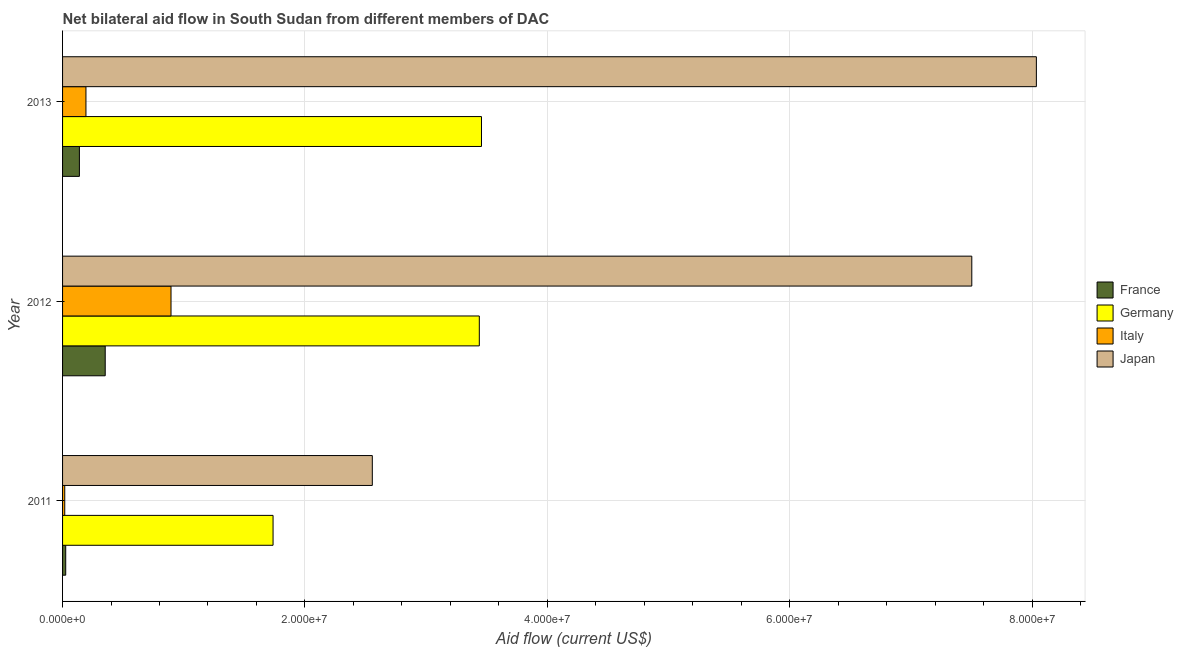Are the number of bars per tick equal to the number of legend labels?
Your response must be concise. Yes. Are the number of bars on each tick of the Y-axis equal?
Make the answer very short. Yes. How many bars are there on the 2nd tick from the bottom?
Provide a succinct answer. 4. In how many cases, is the number of bars for a given year not equal to the number of legend labels?
Offer a terse response. 0. What is the amount of aid given by germany in 2013?
Provide a succinct answer. 3.46e+07. Across all years, what is the maximum amount of aid given by germany?
Your answer should be very brief. 3.46e+07. Across all years, what is the minimum amount of aid given by germany?
Make the answer very short. 1.74e+07. In which year was the amount of aid given by germany maximum?
Your answer should be very brief. 2013. What is the total amount of aid given by japan in the graph?
Offer a terse response. 1.81e+08. What is the difference between the amount of aid given by germany in 2011 and that in 2013?
Your answer should be very brief. -1.72e+07. What is the difference between the amount of aid given by germany in 2012 and the amount of aid given by japan in 2011?
Offer a very short reply. 8.83e+06. What is the average amount of aid given by japan per year?
Provide a short and direct response. 6.03e+07. In the year 2012, what is the difference between the amount of aid given by japan and amount of aid given by germany?
Offer a terse response. 4.06e+07. What is the ratio of the amount of aid given by japan in 2011 to that in 2013?
Your response must be concise. 0.32. Is the amount of aid given by france in 2011 less than that in 2013?
Provide a succinct answer. Yes. What is the difference between the highest and the second highest amount of aid given by italy?
Make the answer very short. 7.02e+06. What is the difference between the highest and the lowest amount of aid given by germany?
Your answer should be very brief. 1.72e+07. In how many years, is the amount of aid given by italy greater than the average amount of aid given by italy taken over all years?
Give a very brief answer. 1. What does the 3rd bar from the top in 2013 represents?
Provide a short and direct response. Germany. What does the 1st bar from the bottom in 2013 represents?
Your answer should be compact. France. Is it the case that in every year, the sum of the amount of aid given by france and amount of aid given by germany is greater than the amount of aid given by italy?
Ensure brevity in your answer.  Yes. How many bars are there?
Make the answer very short. 12. How many years are there in the graph?
Give a very brief answer. 3. Does the graph contain grids?
Your answer should be compact. Yes. Where does the legend appear in the graph?
Your response must be concise. Center right. How many legend labels are there?
Your answer should be very brief. 4. How are the legend labels stacked?
Provide a succinct answer. Vertical. What is the title of the graph?
Provide a short and direct response. Net bilateral aid flow in South Sudan from different members of DAC. Does "UNHCR" appear as one of the legend labels in the graph?
Your response must be concise. No. What is the label or title of the Y-axis?
Provide a short and direct response. Year. What is the Aid flow (current US$) of France in 2011?
Offer a very short reply. 2.60e+05. What is the Aid flow (current US$) in Germany in 2011?
Keep it short and to the point. 1.74e+07. What is the Aid flow (current US$) of Japan in 2011?
Provide a short and direct response. 2.56e+07. What is the Aid flow (current US$) of France in 2012?
Ensure brevity in your answer.  3.52e+06. What is the Aid flow (current US$) of Germany in 2012?
Your answer should be compact. 3.44e+07. What is the Aid flow (current US$) of Italy in 2012?
Your answer should be very brief. 8.95e+06. What is the Aid flow (current US$) in Japan in 2012?
Your answer should be compact. 7.50e+07. What is the Aid flow (current US$) in France in 2013?
Your response must be concise. 1.39e+06. What is the Aid flow (current US$) of Germany in 2013?
Your answer should be very brief. 3.46e+07. What is the Aid flow (current US$) of Italy in 2013?
Provide a short and direct response. 1.93e+06. What is the Aid flow (current US$) of Japan in 2013?
Ensure brevity in your answer.  8.04e+07. Across all years, what is the maximum Aid flow (current US$) in France?
Your answer should be compact. 3.52e+06. Across all years, what is the maximum Aid flow (current US$) of Germany?
Your answer should be compact. 3.46e+07. Across all years, what is the maximum Aid flow (current US$) of Italy?
Provide a succinct answer. 8.95e+06. Across all years, what is the maximum Aid flow (current US$) in Japan?
Give a very brief answer. 8.04e+07. Across all years, what is the minimum Aid flow (current US$) in France?
Your answer should be compact. 2.60e+05. Across all years, what is the minimum Aid flow (current US$) of Germany?
Your answer should be very brief. 1.74e+07. Across all years, what is the minimum Aid flow (current US$) in Italy?
Your answer should be compact. 1.80e+05. Across all years, what is the minimum Aid flow (current US$) of Japan?
Offer a terse response. 2.56e+07. What is the total Aid flow (current US$) of France in the graph?
Provide a succinct answer. 5.17e+06. What is the total Aid flow (current US$) of Germany in the graph?
Your answer should be very brief. 8.63e+07. What is the total Aid flow (current US$) of Italy in the graph?
Ensure brevity in your answer.  1.11e+07. What is the total Aid flow (current US$) in Japan in the graph?
Your answer should be compact. 1.81e+08. What is the difference between the Aid flow (current US$) in France in 2011 and that in 2012?
Ensure brevity in your answer.  -3.26e+06. What is the difference between the Aid flow (current US$) in Germany in 2011 and that in 2012?
Give a very brief answer. -1.70e+07. What is the difference between the Aid flow (current US$) of Italy in 2011 and that in 2012?
Provide a succinct answer. -8.77e+06. What is the difference between the Aid flow (current US$) in Japan in 2011 and that in 2012?
Give a very brief answer. -4.95e+07. What is the difference between the Aid flow (current US$) of France in 2011 and that in 2013?
Provide a succinct answer. -1.13e+06. What is the difference between the Aid flow (current US$) in Germany in 2011 and that in 2013?
Your answer should be compact. -1.72e+07. What is the difference between the Aid flow (current US$) in Italy in 2011 and that in 2013?
Provide a succinct answer. -1.75e+06. What is the difference between the Aid flow (current US$) in Japan in 2011 and that in 2013?
Keep it short and to the point. -5.48e+07. What is the difference between the Aid flow (current US$) of France in 2012 and that in 2013?
Provide a succinct answer. 2.13e+06. What is the difference between the Aid flow (current US$) of Germany in 2012 and that in 2013?
Make the answer very short. -1.80e+05. What is the difference between the Aid flow (current US$) of Italy in 2012 and that in 2013?
Offer a very short reply. 7.02e+06. What is the difference between the Aid flow (current US$) in Japan in 2012 and that in 2013?
Give a very brief answer. -5.33e+06. What is the difference between the Aid flow (current US$) of France in 2011 and the Aid flow (current US$) of Germany in 2012?
Your answer should be compact. -3.41e+07. What is the difference between the Aid flow (current US$) of France in 2011 and the Aid flow (current US$) of Italy in 2012?
Give a very brief answer. -8.69e+06. What is the difference between the Aid flow (current US$) of France in 2011 and the Aid flow (current US$) of Japan in 2012?
Your answer should be very brief. -7.48e+07. What is the difference between the Aid flow (current US$) in Germany in 2011 and the Aid flow (current US$) in Italy in 2012?
Provide a short and direct response. 8.42e+06. What is the difference between the Aid flow (current US$) in Germany in 2011 and the Aid flow (current US$) in Japan in 2012?
Offer a terse response. -5.77e+07. What is the difference between the Aid flow (current US$) of Italy in 2011 and the Aid flow (current US$) of Japan in 2012?
Make the answer very short. -7.48e+07. What is the difference between the Aid flow (current US$) of France in 2011 and the Aid flow (current US$) of Germany in 2013?
Provide a short and direct response. -3.43e+07. What is the difference between the Aid flow (current US$) in France in 2011 and the Aid flow (current US$) in Italy in 2013?
Your response must be concise. -1.67e+06. What is the difference between the Aid flow (current US$) of France in 2011 and the Aid flow (current US$) of Japan in 2013?
Your answer should be compact. -8.01e+07. What is the difference between the Aid flow (current US$) of Germany in 2011 and the Aid flow (current US$) of Italy in 2013?
Your answer should be compact. 1.54e+07. What is the difference between the Aid flow (current US$) in Germany in 2011 and the Aid flow (current US$) in Japan in 2013?
Keep it short and to the point. -6.30e+07. What is the difference between the Aid flow (current US$) of Italy in 2011 and the Aid flow (current US$) of Japan in 2013?
Offer a very short reply. -8.02e+07. What is the difference between the Aid flow (current US$) of France in 2012 and the Aid flow (current US$) of Germany in 2013?
Your answer should be compact. -3.10e+07. What is the difference between the Aid flow (current US$) in France in 2012 and the Aid flow (current US$) in Italy in 2013?
Offer a very short reply. 1.59e+06. What is the difference between the Aid flow (current US$) of France in 2012 and the Aid flow (current US$) of Japan in 2013?
Your answer should be compact. -7.68e+07. What is the difference between the Aid flow (current US$) of Germany in 2012 and the Aid flow (current US$) of Italy in 2013?
Provide a succinct answer. 3.25e+07. What is the difference between the Aid flow (current US$) of Germany in 2012 and the Aid flow (current US$) of Japan in 2013?
Make the answer very short. -4.60e+07. What is the difference between the Aid flow (current US$) of Italy in 2012 and the Aid flow (current US$) of Japan in 2013?
Offer a terse response. -7.14e+07. What is the average Aid flow (current US$) in France per year?
Offer a terse response. 1.72e+06. What is the average Aid flow (current US$) in Germany per year?
Make the answer very short. 2.88e+07. What is the average Aid flow (current US$) of Italy per year?
Provide a succinct answer. 3.69e+06. What is the average Aid flow (current US$) of Japan per year?
Provide a succinct answer. 6.03e+07. In the year 2011, what is the difference between the Aid flow (current US$) of France and Aid flow (current US$) of Germany?
Offer a terse response. -1.71e+07. In the year 2011, what is the difference between the Aid flow (current US$) in France and Aid flow (current US$) in Japan?
Your answer should be very brief. -2.53e+07. In the year 2011, what is the difference between the Aid flow (current US$) in Germany and Aid flow (current US$) in Italy?
Keep it short and to the point. 1.72e+07. In the year 2011, what is the difference between the Aid flow (current US$) of Germany and Aid flow (current US$) of Japan?
Your response must be concise. -8.19e+06. In the year 2011, what is the difference between the Aid flow (current US$) of Italy and Aid flow (current US$) of Japan?
Make the answer very short. -2.54e+07. In the year 2012, what is the difference between the Aid flow (current US$) in France and Aid flow (current US$) in Germany?
Ensure brevity in your answer.  -3.09e+07. In the year 2012, what is the difference between the Aid flow (current US$) in France and Aid flow (current US$) in Italy?
Your answer should be compact. -5.43e+06. In the year 2012, what is the difference between the Aid flow (current US$) in France and Aid flow (current US$) in Japan?
Ensure brevity in your answer.  -7.15e+07. In the year 2012, what is the difference between the Aid flow (current US$) in Germany and Aid flow (current US$) in Italy?
Offer a very short reply. 2.54e+07. In the year 2012, what is the difference between the Aid flow (current US$) in Germany and Aid flow (current US$) in Japan?
Offer a terse response. -4.06e+07. In the year 2012, what is the difference between the Aid flow (current US$) of Italy and Aid flow (current US$) of Japan?
Your answer should be very brief. -6.61e+07. In the year 2013, what is the difference between the Aid flow (current US$) of France and Aid flow (current US$) of Germany?
Provide a succinct answer. -3.32e+07. In the year 2013, what is the difference between the Aid flow (current US$) in France and Aid flow (current US$) in Italy?
Your answer should be compact. -5.40e+05. In the year 2013, what is the difference between the Aid flow (current US$) in France and Aid flow (current US$) in Japan?
Ensure brevity in your answer.  -7.90e+07. In the year 2013, what is the difference between the Aid flow (current US$) in Germany and Aid flow (current US$) in Italy?
Offer a very short reply. 3.26e+07. In the year 2013, what is the difference between the Aid flow (current US$) of Germany and Aid flow (current US$) of Japan?
Provide a short and direct response. -4.58e+07. In the year 2013, what is the difference between the Aid flow (current US$) in Italy and Aid flow (current US$) in Japan?
Provide a succinct answer. -7.84e+07. What is the ratio of the Aid flow (current US$) of France in 2011 to that in 2012?
Provide a succinct answer. 0.07. What is the ratio of the Aid flow (current US$) of Germany in 2011 to that in 2012?
Offer a very short reply. 0.51. What is the ratio of the Aid flow (current US$) in Italy in 2011 to that in 2012?
Offer a terse response. 0.02. What is the ratio of the Aid flow (current US$) of Japan in 2011 to that in 2012?
Offer a very short reply. 0.34. What is the ratio of the Aid flow (current US$) in France in 2011 to that in 2013?
Offer a terse response. 0.19. What is the ratio of the Aid flow (current US$) in Germany in 2011 to that in 2013?
Give a very brief answer. 0.5. What is the ratio of the Aid flow (current US$) in Italy in 2011 to that in 2013?
Provide a short and direct response. 0.09. What is the ratio of the Aid flow (current US$) of Japan in 2011 to that in 2013?
Give a very brief answer. 0.32. What is the ratio of the Aid flow (current US$) in France in 2012 to that in 2013?
Your answer should be compact. 2.53. What is the ratio of the Aid flow (current US$) of Germany in 2012 to that in 2013?
Make the answer very short. 0.99. What is the ratio of the Aid flow (current US$) in Italy in 2012 to that in 2013?
Provide a short and direct response. 4.64. What is the ratio of the Aid flow (current US$) in Japan in 2012 to that in 2013?
Provide a succinct answer. 0.93. What is the difference between the highest and the second highest Aid flow (current US$) of France?
Make the answer very short. 2.13e+06. What is the difference between the highest and the second highest Aid flow (current US$) of Italy?
Your answer should be very brief. 7.02e+06. What is the difference between the highest and the second highest Aid flow (current US$) of Japan?
Your response must be concise. 5.33e+06. What is the difference between the highest and the lowest Aid flow (current US$) of France?
Give a very brief answer. 3.26e+06. What is the difference between the highest and the lowest Aid flow (current US$) of Germany?
Your response must be concise. 1.72e+07. What is the difference between the highest and the lowest Aid flow (current US$) of Italy?
Your response must be concise. 8.77e+06. What is the difference between the highest and the lowest Aid flow (current US$) in Japan?
Keep it short and to the point. 5.48e+07. 